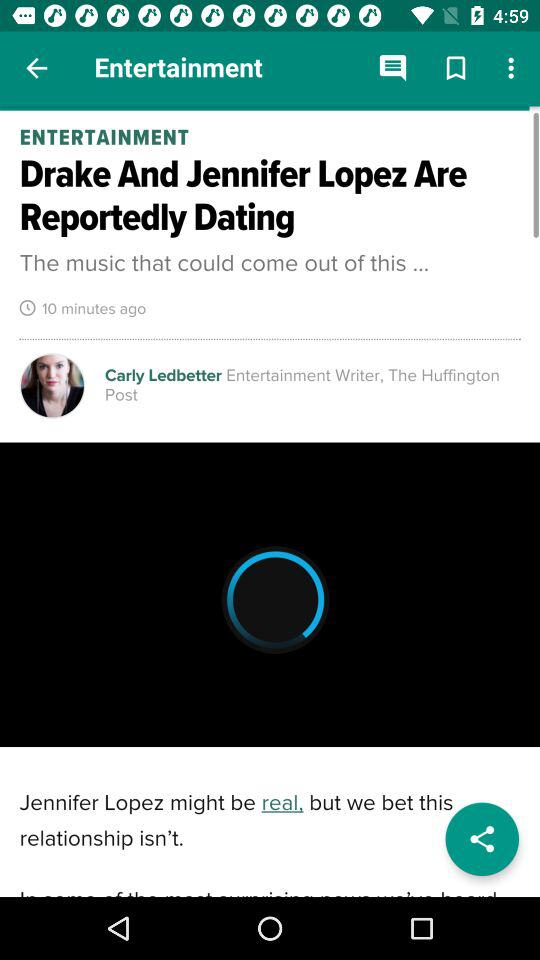What's the published time? The published time is 10 minutes ago. 